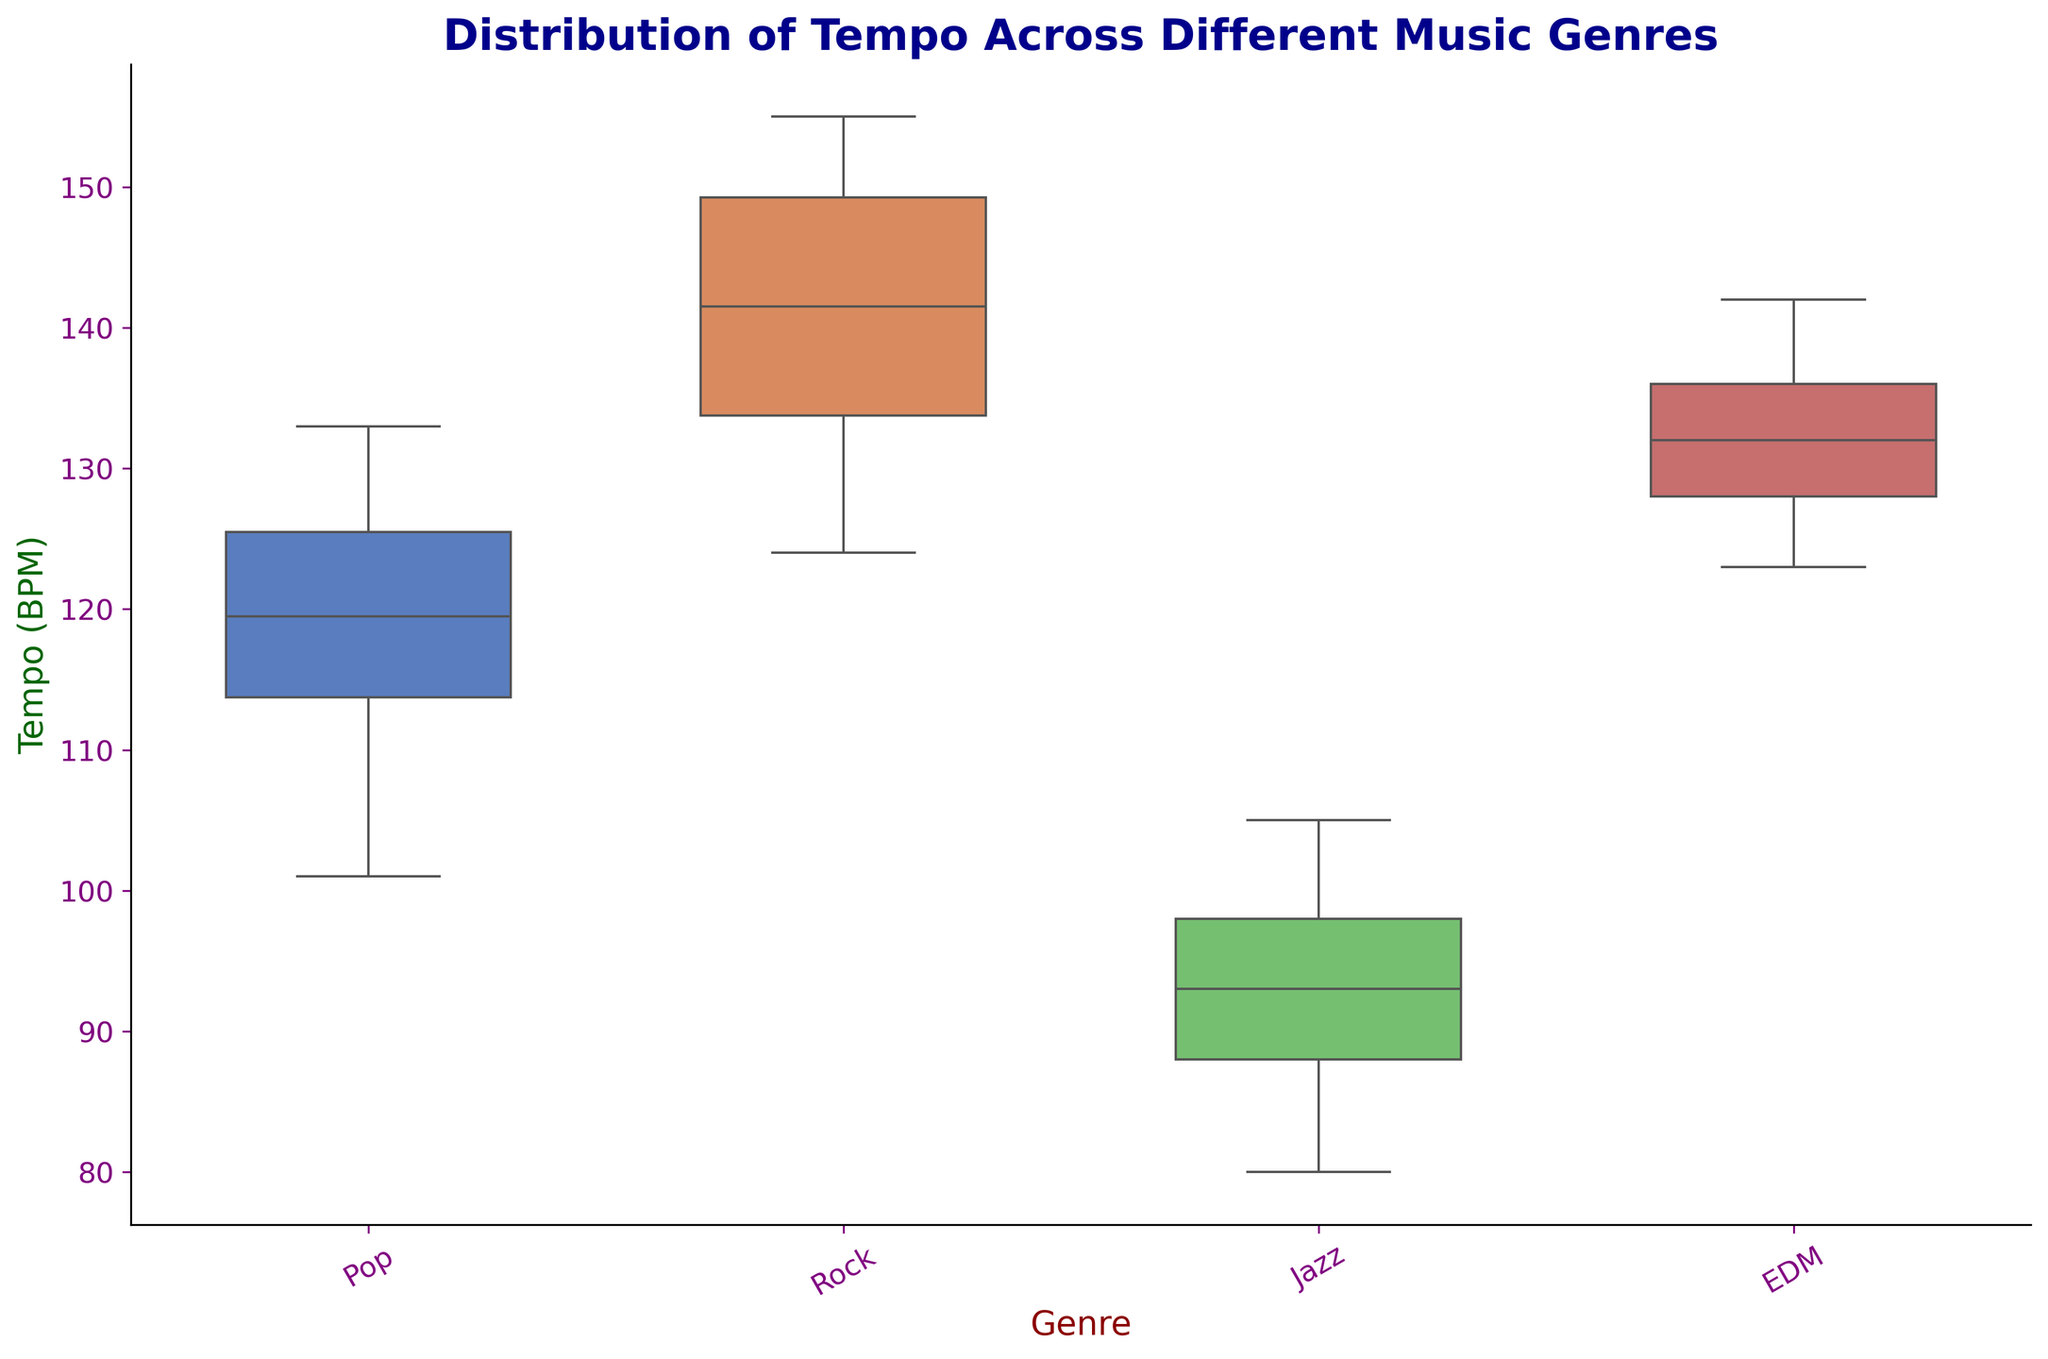What is the median tempo of Pop music? To find the median tempo of Pop music, locate the middle value of the sorted tempo values for the Pop genre. The tempo values for Pop sorted in ascending order are [101, 107, 110, 115, 118, 119, 120, 123, 125, 127, 130, 133]. The median, or the middle value, is the average of the 6th and 7th values: (119 + 120) / 2 = 119.5.
Answer: 119.5 Which genre has the largest range in tempo? To determine which genre has the largest range in tempo, calculate the difference between the maximum and minimum tempo values for each genre. Pop ranges from 101 to 133 (range = 32), Rock ranges from 124 to 155 (range = 31), Jazz ranges from 80 to 105 (range = 25), and EDM ranges from 123 to 142 (range = 19). Therefore, Pop has the largest range.
Answer: Pop What is the interquartile range (IQR) for Jazz tempo? The IQR is the difference between the 75th percentile (Q3) and the 25th percentile (Q1). For Jazz, Q1 is around 88 and Q3 is around 100, based on the box plot visual. Thus, IQR = Q3 - Q1 = 100 - 88 = 12.
Answer: 12 Which genre seems to have the most consistent tempo based on the box plot? Consistency in tempo can be indicated by a smaller IQR or range. Comparing the box plots, EDM has the smallest range and a tight IQR, indicating it has the most consistent tempo.
Answer: EDM Is there any genre with outliers in the tempo distribution? Inspecting the box plots for any points that fall outside the whiskers indicates outliers. In the Pop genre, there are low outlier points (below the whiskers).
Answer: Yes, Pop Which genre has the highest median tempo? By examining the central line within each box in the box plot, we can determine the median values. Rock has the highest median tempo as its median line is higher than all other genres.
Answer: Rock How does the variability in tempo for EDM compare to Jazz? Variability can be assessed by comparing the lengths of the boxes (IQR) and the ranges (distance between the whiskers) of both genres. EDM box plot is shorter in both IQR and overall range than Jazz, indicating less variability in EDM.
Answer: Less variable What is the median tempo for Rock and EDM combined? First, combine the tempo values from both Rock and EDM: [124, 125, 127, 128, 129, 130, 130, 132, 134, 135, 136, 138, 138, 140, 142, 143, 145, 149, 150, 152, 155]. Sort and find the median: the sorted list is the same as combined, and the median is the 11th value, 135.
Answer: 135 Which genre has the lowest minimum tempo? By checking the lowest point of each box plot, Jazz has the lowest minimum tempo at 80 BPM.
Answer: Jazz How many genres have a median tempo above 120 BPM? By observing the central lines of each box plot, Rock, Pop, and EDM all have medians above 120 BPM.
Answer: Three 